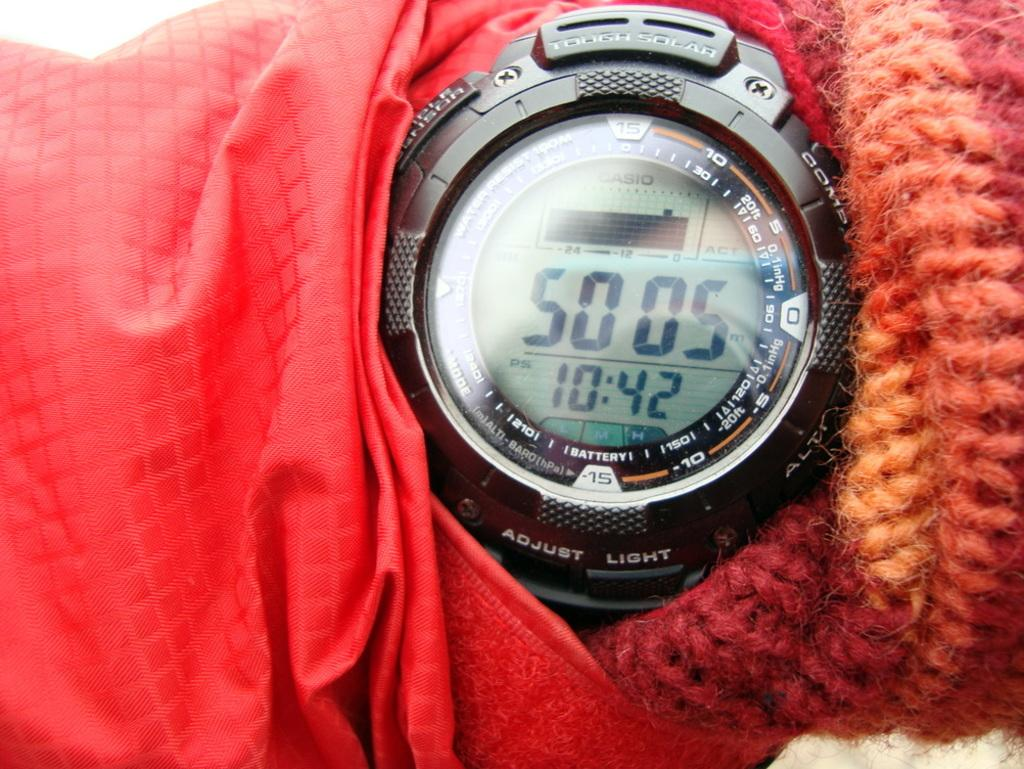<image>
Relay a brief, clear account of the picture shown. A Casio stopwatch reads 50 minutes and 5 seconds. 